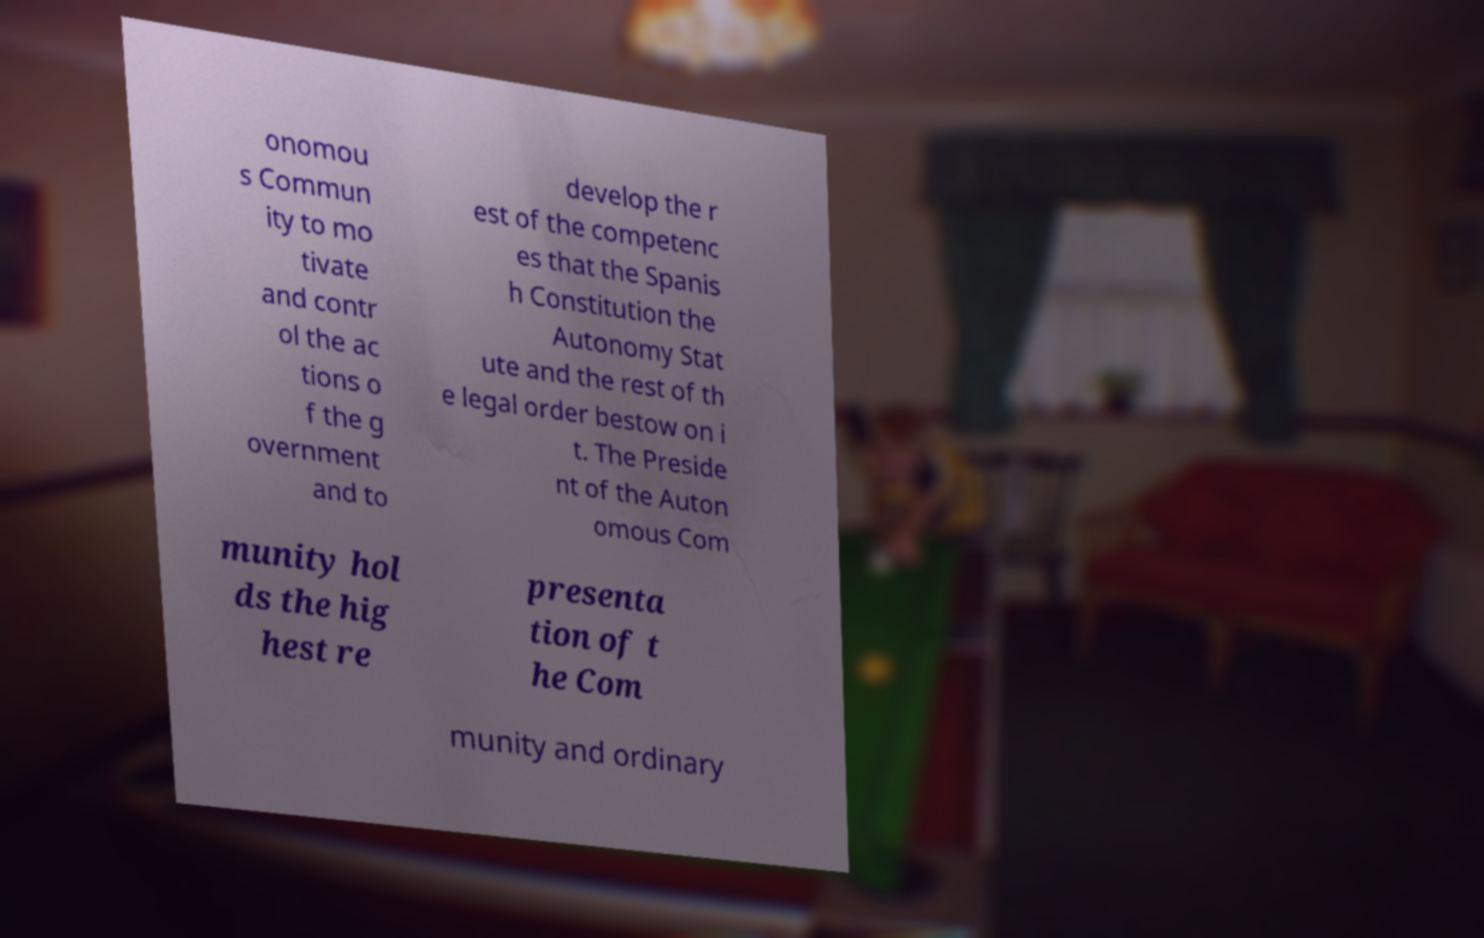What messages or text are displayed in this image? I need them in a readable, typed format. onomou s Commun ity to mo tivate and contr ol the ac tions o f the g overnment and to develop the r est of the competenc es that the Spanis h Constitution the Autonomy Stat ute and the rest of th e legal order bestow on i t. The Preside nt of the Auton omous Com munity hol ds the hig hest re presenta tion of t he Com munity and ordinary 